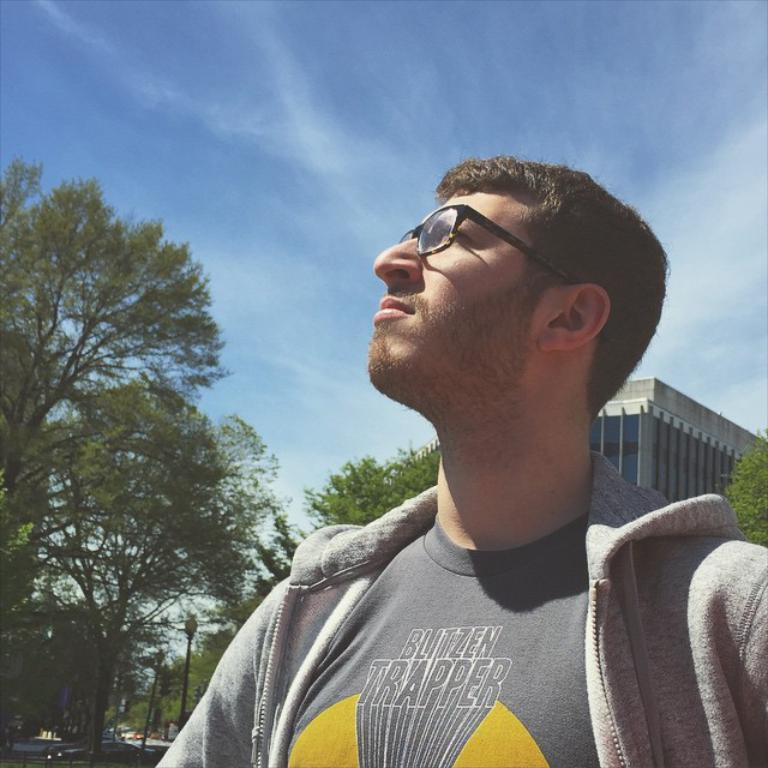Who is the main subject in the foreground of the image? There is a man in the foreground of the image. What is the man wearing in the image? The man is wearing spectacles in the image. What can be seen in the background of the image? There are houses and trees in the background of the image. What is visible at the top of the image? The sky is visible at the top of the image. Can you see a yak in the image? No, there is no yak present in the image. 